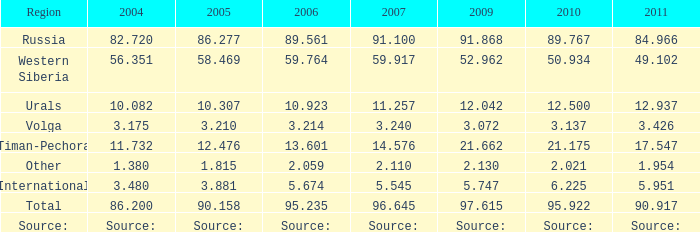What is the 2005 lukoil oil output when in 2007 oil production was 3.881. 